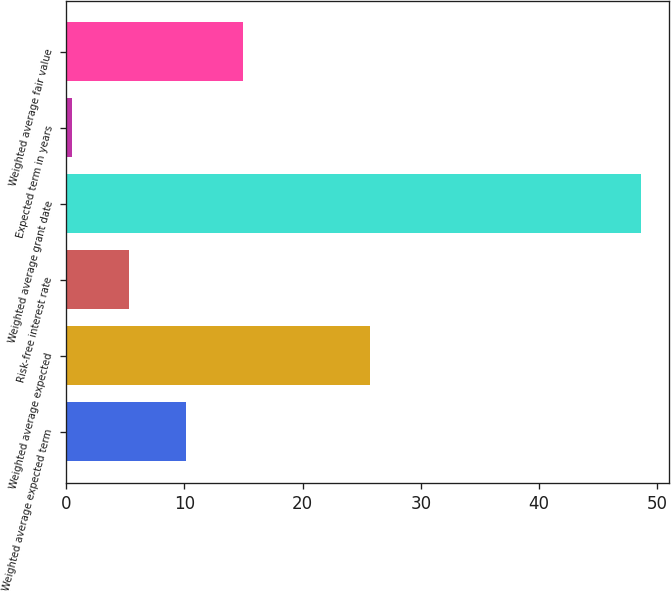Convert chart to OTSL. <chart><loc_0><loc_0><loc_500><loc_500><bar_chart><fcel>Weighted average expected term<fcel>Weighted average expected<fcel>Risk-free interest rate<fcel>Weighted average grant date<fcel>Expected term in years<fcel>Weighted average fair value<nl><fcel>10.12<fcel>25.7<fcel>5.31<fcel>48.57<fcel>0.5<fcel>14.93<nl></chart> 